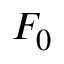Convert formula to latex. <formula><loc_0><loc_0><loc_500><loc_500>F _ { 0 }</formula> 